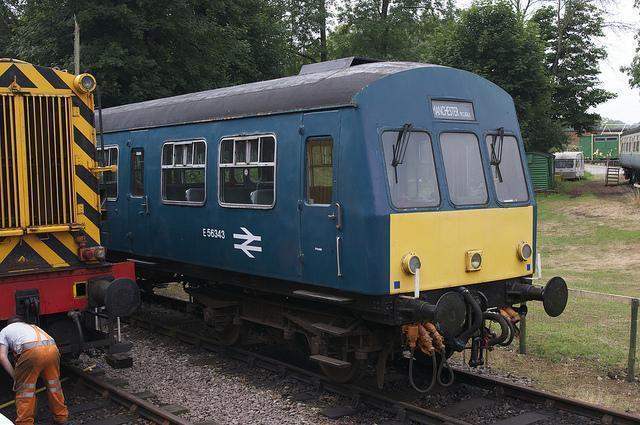What are the black circular pieces on the front of the train?
From the following four choices, select the correct answer to address the question.
Options: Frisbees, bumpers, guns, holders. Bumpers. 